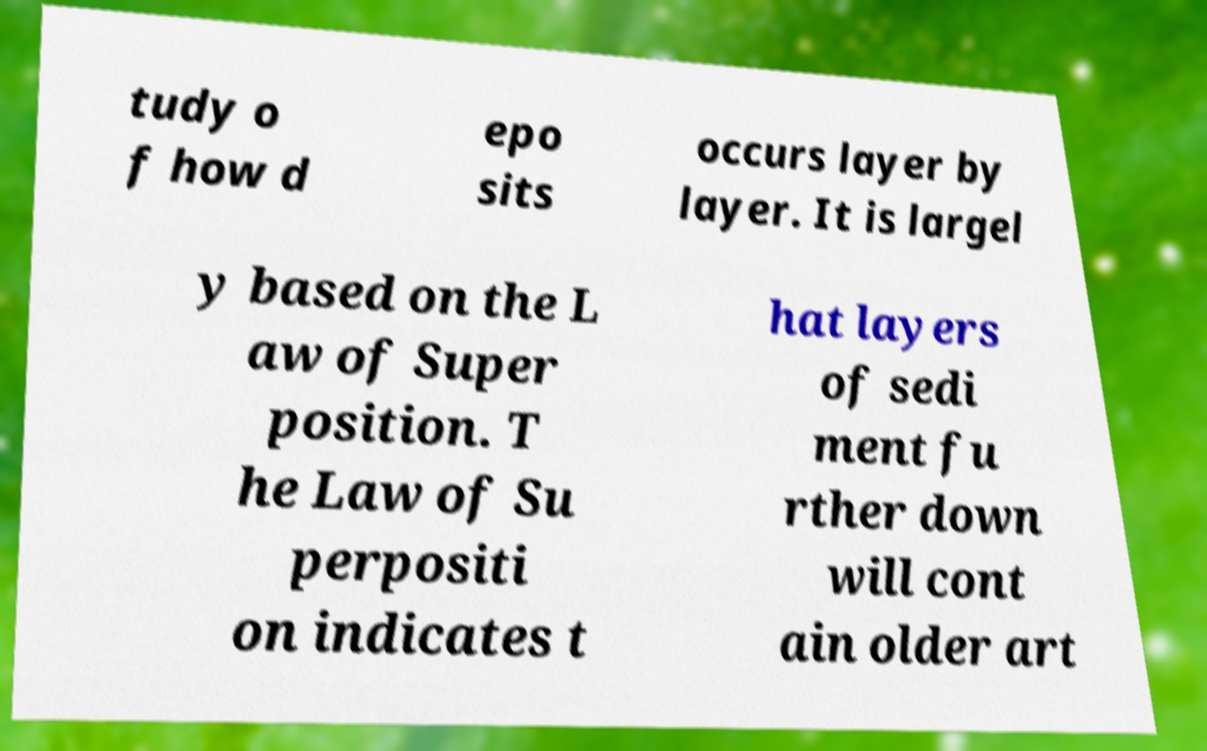I need the written content from this picture converted into text. Can you do that? tudy o f how d epo sits occurs layer by layer. It is largel y based on the L aw of Super position. T he Law of Su perpositi on indicates t hat layers of sedi ment fu rther down will cont ain older art 